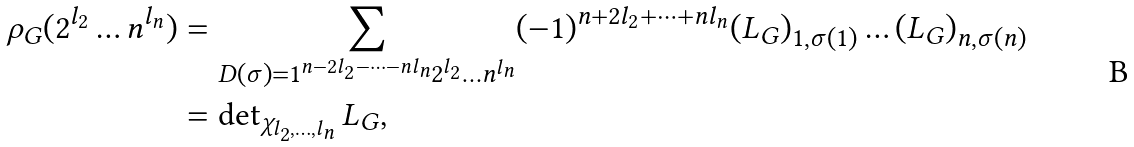Convert formula to latex. <formula><loc_0><loc_0><loc_500><loc_500>\rho _ { G } ( 2 ^ { l _ { 2 } } \dots n ^ { l _ { n } } ) & = \sum _ { D ( \sigma ) = 1 ^ { n - 2 l _ { 2 } - \dots - n l _ { n } } 2 ^ { l _ { 2 } } \dots n ^ { l _ { n } } } ( - 1 ) ^ { n + 2 l _ { 2 } + \dots + n l _ { n } } ( L _ { G } ) _ { 1 , \sigma ( 1 ) } \dots ( L _ { G } ) _ { n , \sigma ( n ) } \\ & = \det \nolimits _ { \chi _ { l _ { 2 } , \dots , l _ { n } } } L _ { G } ,</formula> 